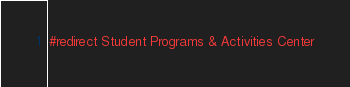Convert code to text. <code><loc_0><loc_0><loc_500><loc_500><_FORTRAN_>#redirect Student Programs & Activities Center
</code> 